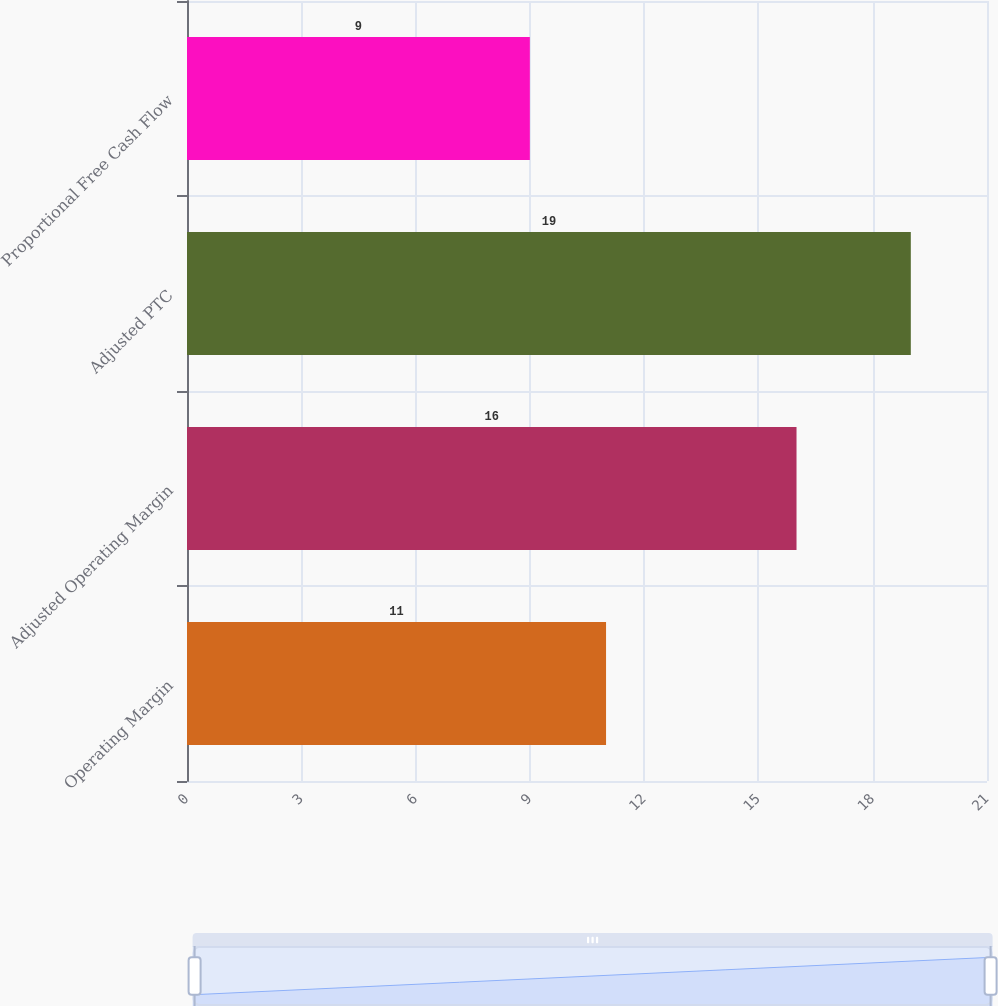Convert chart. <chart><loc_0><loc_0><loc_500><loc_500><bar_chart><fcel>Operating Margin<fcel>Adjusted Operating Margin<fcel>Adjusted PTC<fcel>Proportional Free Cash Flow<nl><fcel>11<fcel>16<fcel>19<fcel>9<nl></chart> 